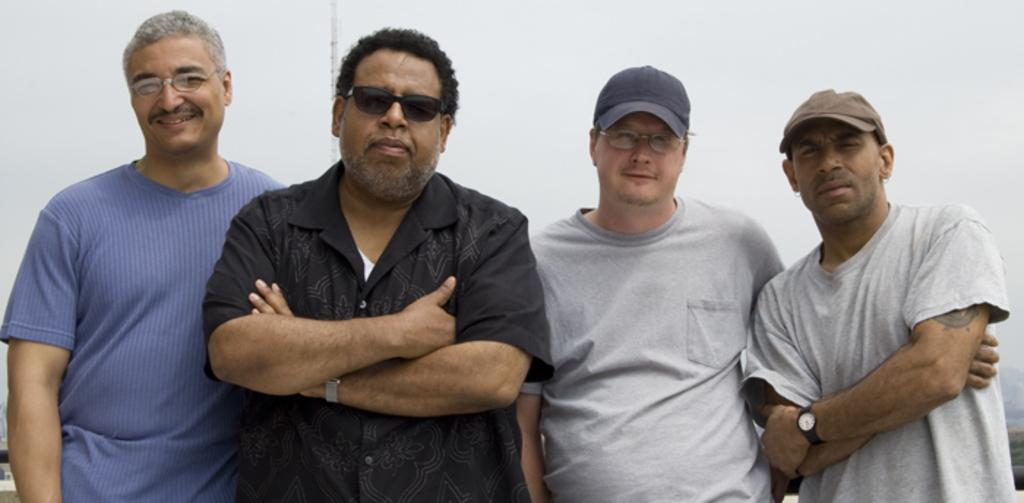What is the main subject of the image? The main subject of the image is a group of men. What are the men doing in the image? The men are standing together and posing for a photograph. What language are the girls speaking in the image? There are no girls present in the image, and therefore no language can be attributed to them. 